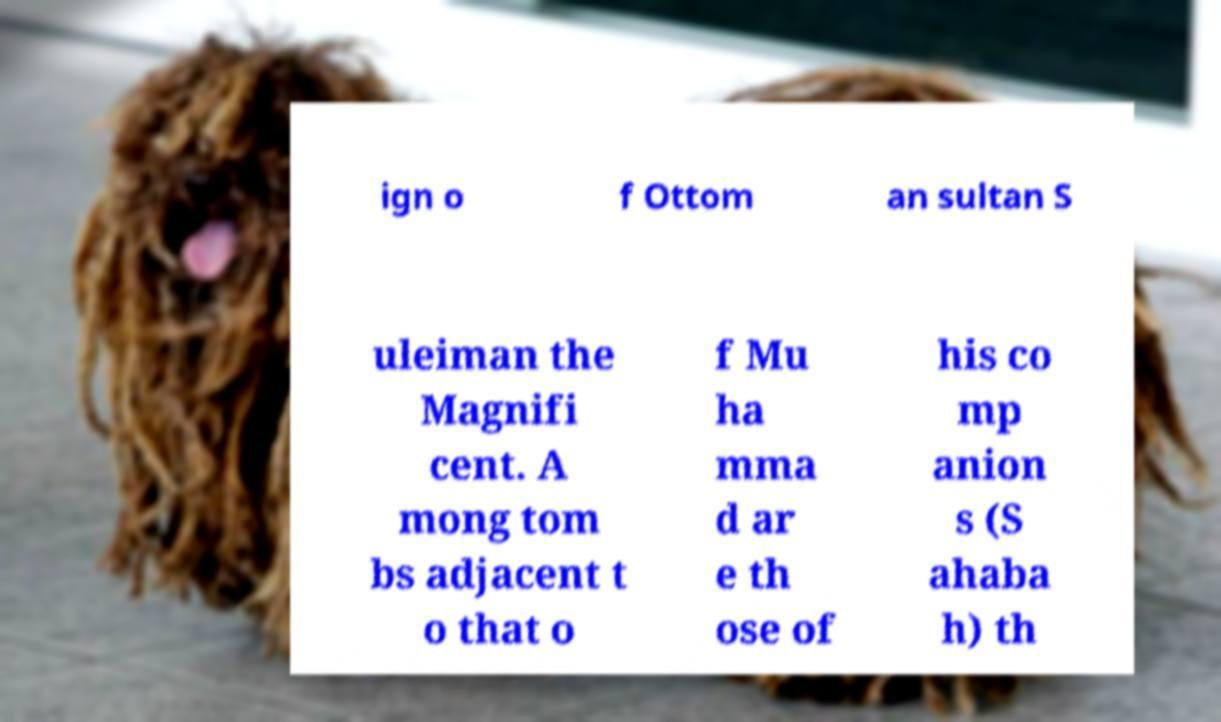Could you extract and type out the text from this image? ign o f Ottom an sultan S uleiman the Magnifi cent. A mong tom bs adjacent t o that o f Mu ha mma d ar e th ose of his co mp anion s (S ahaba h) th 